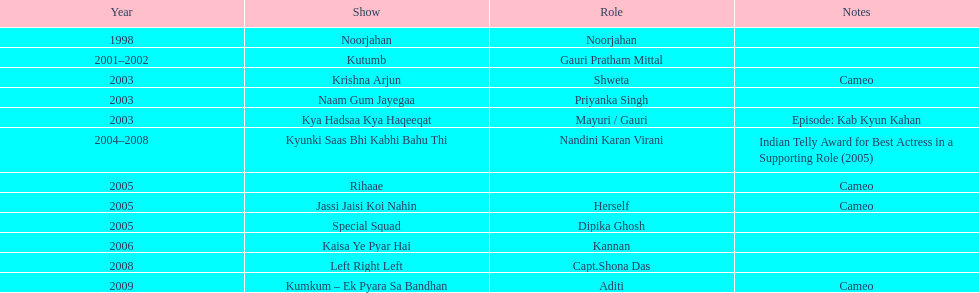How many total television shows has gauri starred in? 12. 